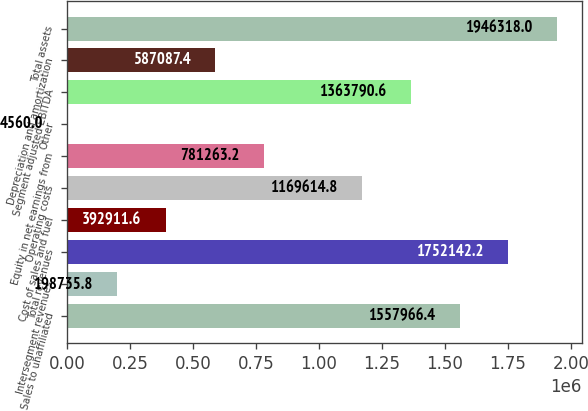<chart> <loc_0><loc_0><loc_500><loc_500><bar_chart><fcel>Sales to unaffiliated<fcel>Intersegment revenues<fcel>Total revenues<fcel>Cost of sales and fuel<fcel>Operating costs<fcel>Equity in net earnings from<fcel>Other<fcel>Segment adjusted EBITDA<fcel>Depreciation and amortization<fcel>Total assets<nl><fcel>1.55797e+06<fcel>198736<fcel>1.75214e+06<fcel>392912<fcel>1.16961e+06<fcel>781263<fcel>4560<fcel>1.36379e+06<fcel>587087<fcel>1.94632e+06<nl></chart> 